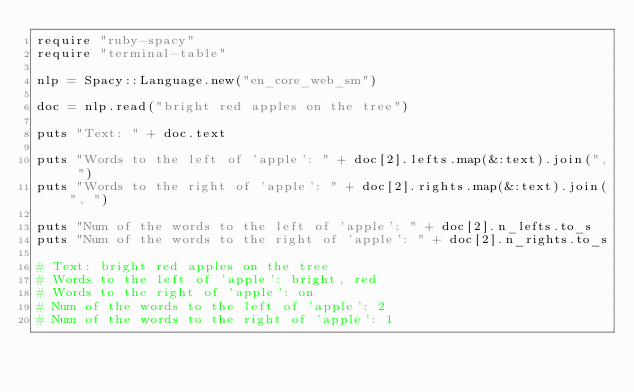Convert code to text. <code><loc_0><loc_0><loc_500><loc_500><_Ruby_>require "ruby-spacy"
require "terminal-table"

nlp = Spacy::Language.new("en_core_web_sm")

doc = nlp.read("bright red apples on the tree")

puts "Text: " + doc.text

puts "Words to the left of 'apple': " + doc[2].lefts.map(&:text).join(", ")
puts "Words to the right of 'apple': " + doc[2].rights.map(&:text).join(", ")

puts "Num of the words to the left of 'apple': " + doc[2].n_lefts.to_s
puts "Num of the words to the right of 'apple': " + doc[2].n_rights.to_s

# Text: bright red apples on the tree
# Words to the left of 'apple': bright, red
# Words to the right of 'apple': on
# Num of the words to the left of 'apple': 2
# Num of the words to the right of 'apple': 1
</code> 